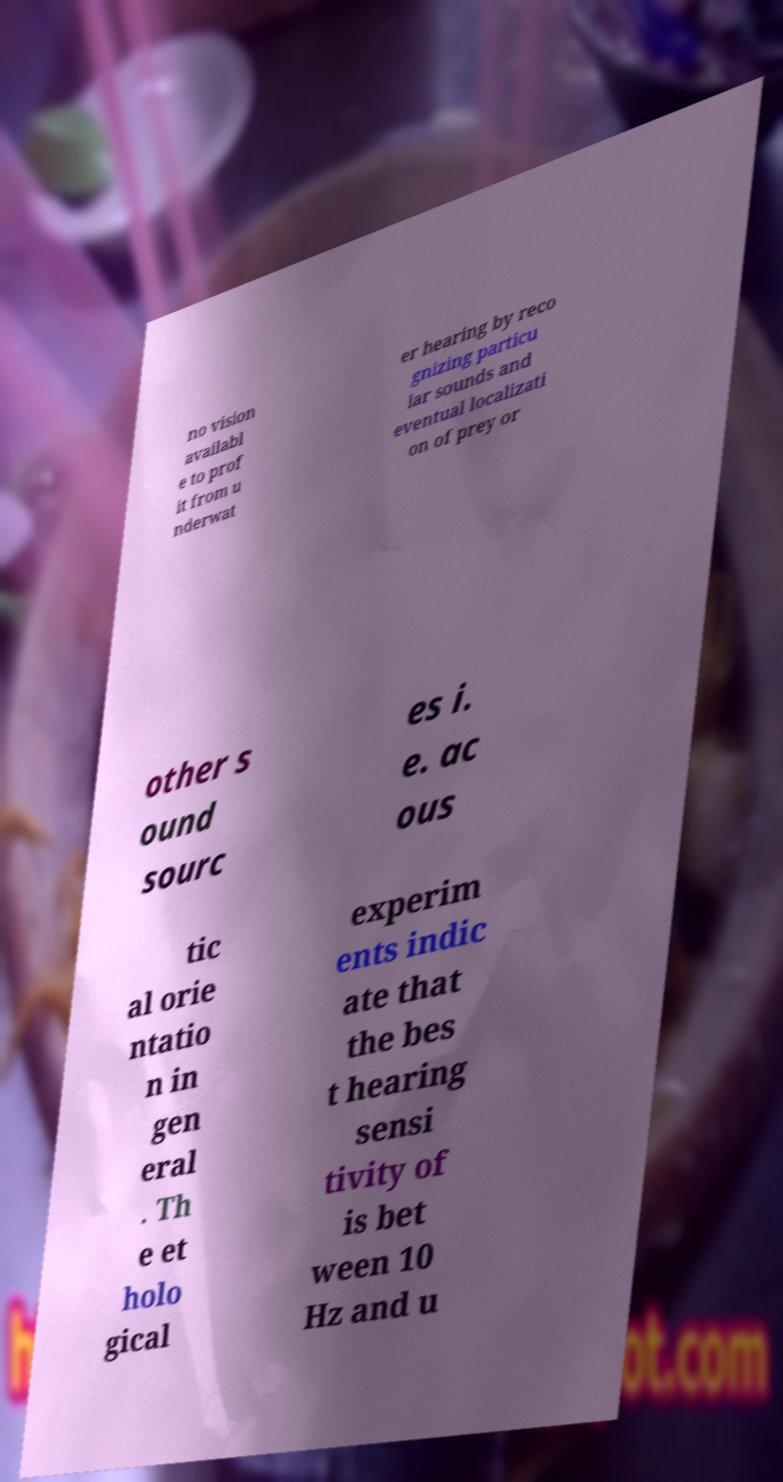Could you extract and type out the text from this image? no vision availabl e to prof it from u nderwat er hearing by reco gnizing particu lar sounds and eventual localizati on of prey or other s ound sourc es i. e. ac ous tic al orie ntatio n in gen eral . Th e et holo gical experim ents indic ate that the bes t hearing sensi tivity of is bet ween 10 Hz and u 